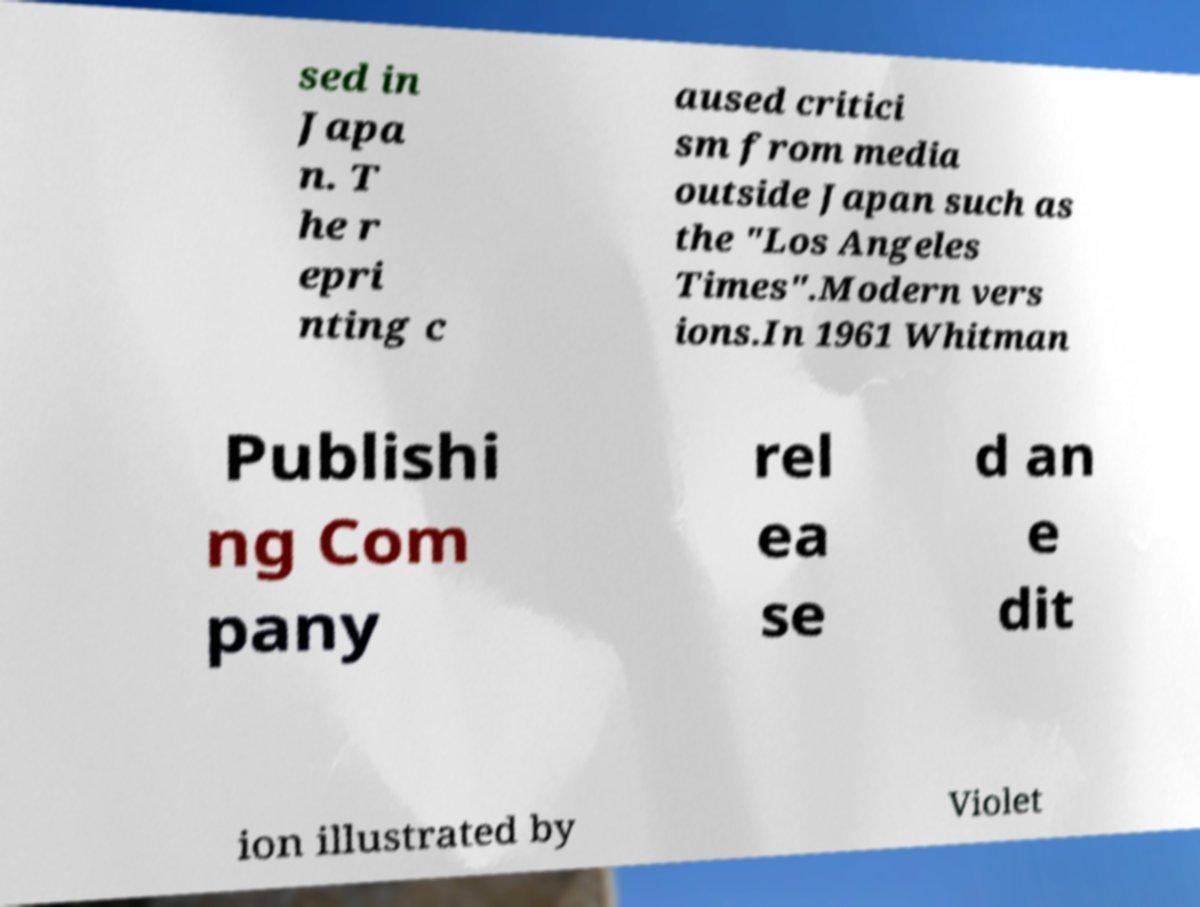What messages or text are displayed in this image? I need them in a readable, typed format. sed in Japa n. T he r epri nting c aused critici sm from media outside Japan such as the "Los Angeles Times".Modern vers ions.In 1961 Whitman Publishi ng Com pany rel ea se d an e dit ion illustrated by Violet 